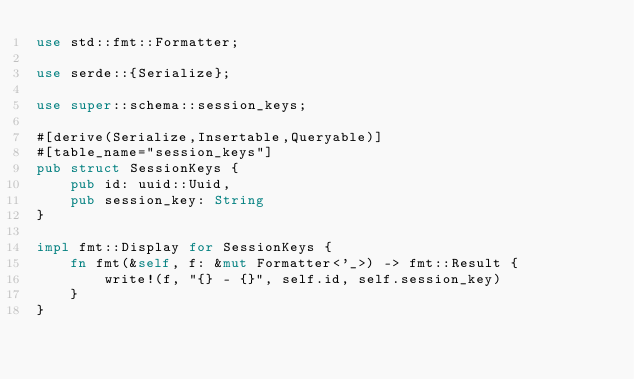<code> <loc_0><loc_0><loc_500><loc_500><_Rust_>use std::fmt::Formatter;

use serde::{Serialize};

use super::schema::session_keys;

#[derive(Serialize,Insertable,Queryable)]
#[table_name="session_keys"]
pub struct SessionKeys {
    pub id: uuid::Uuid,
    pub session_key: String
}

impl fmt::Display for SessionKeys {
    fn fmt(&self, f: &mut Formatter<'_>) -> fmt::Result {
        write!(f, "{} - {}", self.id, self.session_key)
    }
}
</code> 